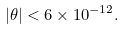<formula> <loc_0><loc_0><loc_500><loc_500>| \theta | < 6 \times 1 0 ^ { - 1 2 } .</formula> 